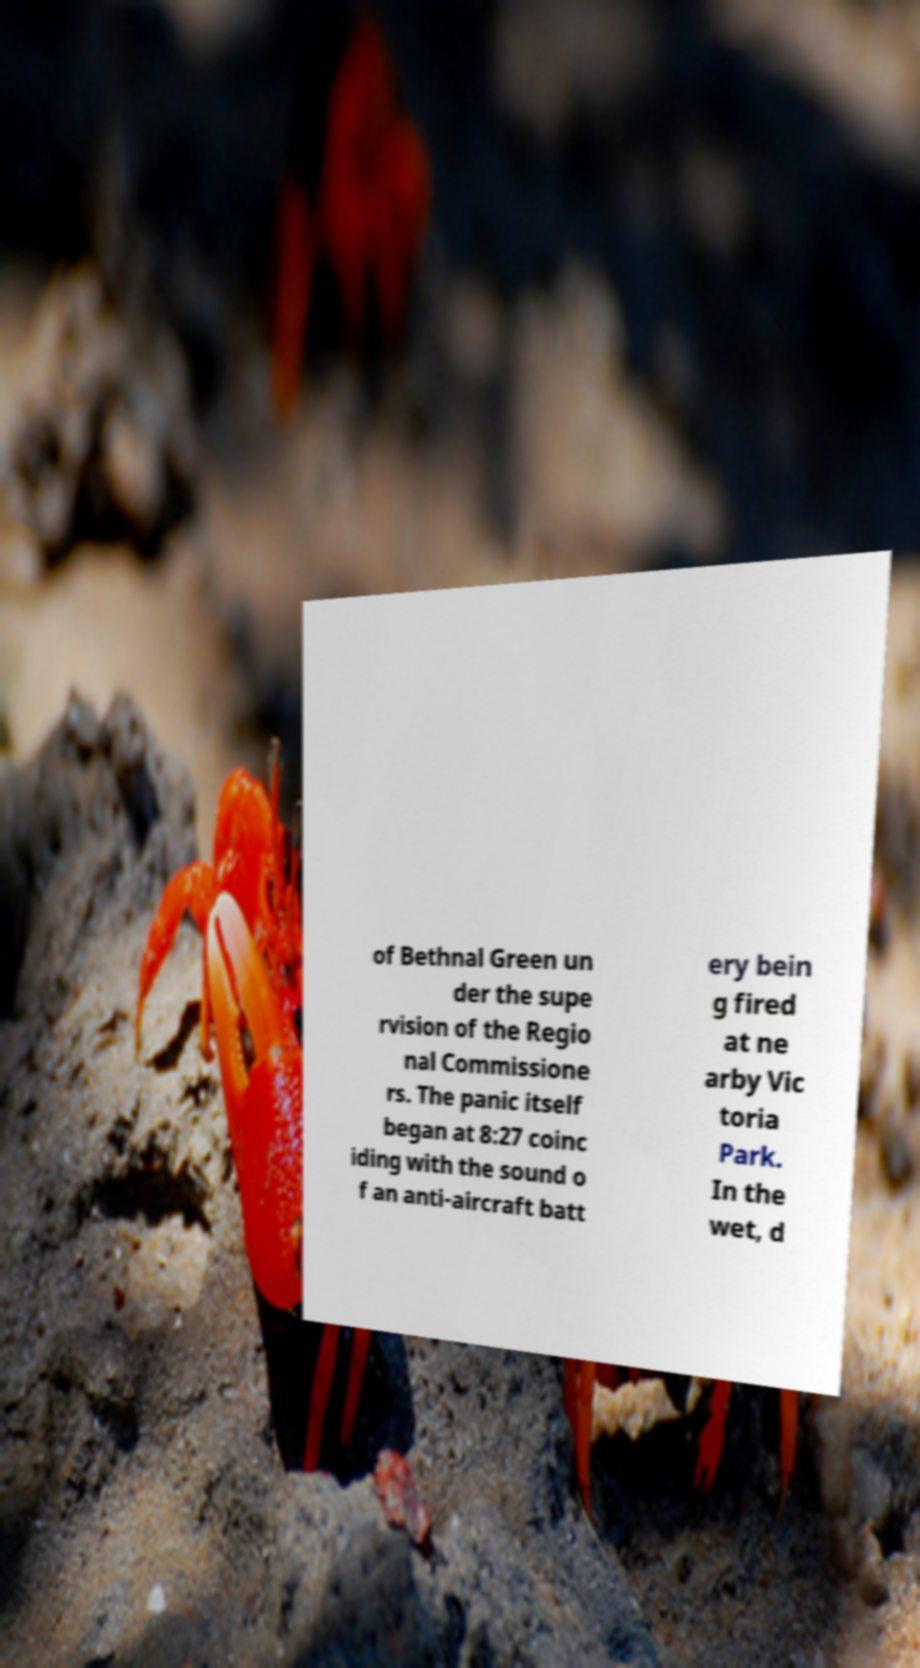Can you read and provide the text displayed in the image?This photo seems to have some interesting text. Can you extract and type it out for me? of Bethnal Green un der the supe rvision of the Regio nal Commissione rs. The panic itself began at 8:27 coinc iding with the sound o f an anti-aircraft batt ery bein g fired at ne arby Vic toria Park. In the wet, d 